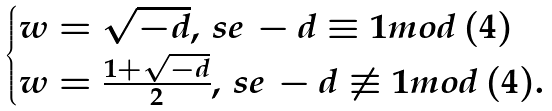Convert formula to latex. <formula><loc_0><loc_0><loc_500><loc_500>\begin{cases} w = \sqrt { - d } , \, s e \, - d \equiv 1 m o d \, ( 4 ) \\ w = \frac { 1 + \sqrt { - d } } { 2 } , \, s e \, - d \not \equiv 1 m o d \, ( 4 ) . \end{cases}</formula> 